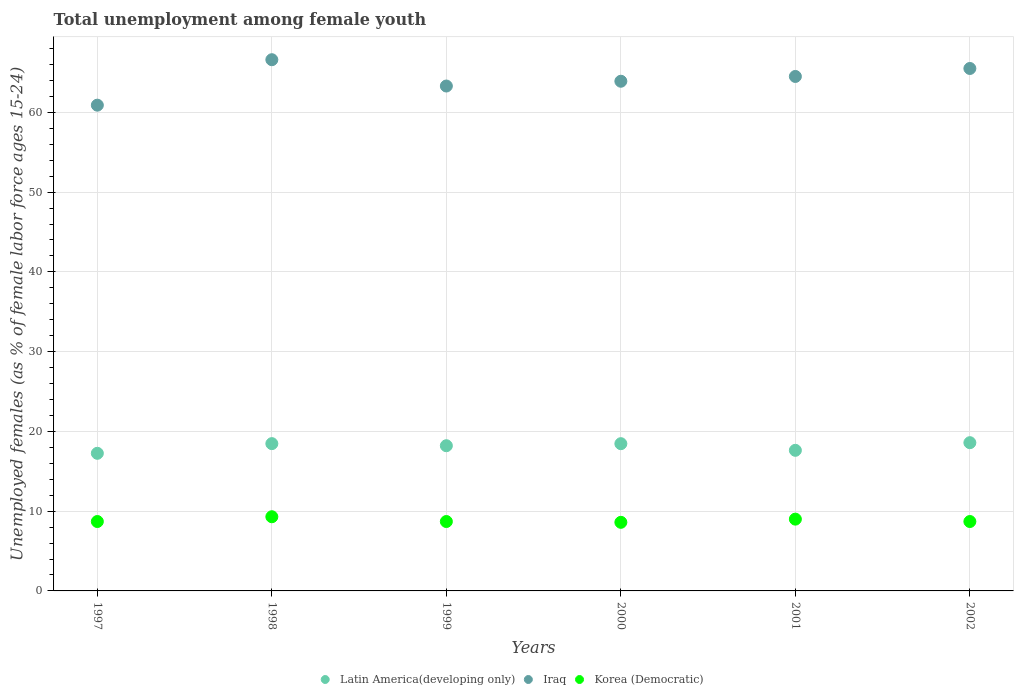What is the percentage of unemployed females in in Latin America(developing only) in 2001?
Provide a succinct answer. 17.63. Across all years, what is the maximum percentage of unemployed females in in Korea (Democratic)?
Keep it short and to the point. 9.3. Across all years, what is the minimum percentage of unemployed females in in Latin America(developing only)?
Offer a very short reply. 17.25. In which year was the percentage of unemployed females in in Korea (Democratic) maximum?
Offer a very short reply. 1998. What is the total percentage of unemployed females in in Latin America(developing only) in the graph?
Provide a succinct answer. 108.59. What is the difference between the percentage of unemployed females in in Korea (Democratic) in 1998 and that in 1999?
Offer a terse response. 0.6. What is the difference between the percentage of unemployed females in in Latin America(developing only) in 2002 and the percentage of unemployed females in in Iraq in 2001?
Give a very brief answer. -45.91. What is the average percentage of unemployed females in in Latin America(developing only) per year?
Provide a succinct answer. 18.1. In the year 1998, what is the difference between the percentage of unemployed females in in Korea (Democratic) and percentage of unemployed females in in Latin America(developing only)?
Make the answer very short. -9.17. In how many years, is the percentage of unemployed females in in Latin America(developing only) greater than 42 %?
Your answer should be very brief. 0. What is the ratio of the percentage of unemployed females in in Latin America(developing only) in 1998 to that in 2002?
Your answer should be very brief. 0.99. Is the percentage of unemployed females in in Iraq in 2000 less than that in 2001?
Your response must be concise. Yes. Is the difference between the percentage of unemployed females in in Korea (Democratic) in 1997 and 2000 greater than the difference between the percentage of unemployed females in in Latin America(developing only) in 1997 and 2000?
Your answer should be compact. Yes. What is the difference between the highest and the second highest percentage of unemployed females in in Korea (Democratic)?
Keep it short and to the point. 0.3. What is the difference between the highest and the lowest percentage of unemployed females in in Korea (Democratic)?
Your answer should be compact. 0.7. Does the percentage of unemployed females in in Iraq monotonically increase over the years?
Offer a very short reply. No. Is the percentage of unemployed females in in Korea (Democratic) strictly greater than the percentage of unemployed females in in Latin America(developing only) over the years?
Your answer should be compact. No. How many years are there in the graph?
Ensure brevity in your answer.  6. Are the values on the major ticks of Y-axis written in scientific E-notation?
Your response must be concise. No. Does the graph contain grids?
Provide a succinct answer. Yes. Where does the legend appear in the graph?
Give a very brief answer. Bottom center. How many legend labels are there?
Offer a terse response. 3. What is the title of the graph?
Give a very brief answer. Total unemployment among female youth. Does "East Asia (developing only)" appear as one of the legend labels in the graph?
Provide a succinct answer. No. What is the label or title of the X-axis?
Provide a short and direct response. Years. What is the label or title of the Y-axis?
Your answer should be compact. Unemployed females (as % of female labor force ages 15-24). What is the Unemployed females (as % of female labor force ages 15-24) in Latin America(developing only) in 1997?
Give a very brief answer. 17.25. What is the Unemployed females (as % of female labor force ages 15-24) of Iraq in 1997?
Give a very brief answer. 60.9. What is the Unemployed females (as % of female labor force ages 15-24) in Korea (Democratic) in 1997?
Ensure brevity in your answer.  8.7. What is the Unemployed females (as % of female labor force ages 15-24) in Latin America(developing only) in 1998?
Keep it short and to the point. 18.47. What is the Unemployed females (as % of female labor force ages 15-24) of Iraq in 1998?
Provide a succinct answer. 66.6. What is the Unemployed females (as % of female labor force ages 15-24) in Korea (Democratic) in 1998?
Your response must be concise. 9.3. What is the Unemployed females (as % of female labor force ages 15-24) in Latin America(developing only) in 1999?
Give a very brief answer. 18.2. What is the Unemployed females (as % of female labor force ages 15-24) of Iraq in 1999?
Your answer should be very brief. 63.3. What is the Unemployed females (as % of female labor force ages 15-24) in Korea (Democratic) in 1999?
Provide a succinct answer. 8.7. What is the Unemployed females (as % of female labor force ages 15-24) in Latin America(developing only) in 2000?
Keep it short and to the point. 18.46. What is the Unemployed females (as % of female labor force ages 15-24) of Iraq in 2000?
Offer a very short reply. 63.9. What is the Unemployed females (as % of female labor force ages 15-24) in Korea (Democratic) in 2000?
Provide a short and direct response. 8.6. What is the Unemployed females (as % of female labor force ages 15-24) in Latin America(developing only) in 2001?
Your answer should be compact. 17.63. What is the Unemployed females (as % of female labor force ages 15-24) of Iraq in 2001?
Offer a very short reply. 64.5. What is the Unemployed females (as % of female labor force ages 15-24) in Latin America(developing only) in 2002?
Provide a short and direct response. 18.59. What is the Unemployed females (as % of female labor force ages 15-24) of Iraq in 2002?
Your answer should be very brief. 65.5. What is the Unemployed females (as % of female labor force ages 15-24) of Korea (Democratic) in 2002?
Your answer should be compact. 8.7. Across all years, what is the maximum Unemployed females (as % of female labor force ages 15-24) of Latin America(developing only)?
Ensure brevity in your answer.  18.59. Across all years, what is the maximum Unemployed females (as % of female labor force ages 15-24) of Iraq?
Make the answer very short. 66.6. Across all years, what is the maximum Unemployed females (as % of female labor force ages 15-24) of Korea (Democratic)?
Provide a short and direct response. 9.3. Across all years, what is the minimum Unemployed females (as % of female labor force ages 15-24) in Latin America(developing only)?
Provide a succinct answer. 17.25. Across all years, what is the minimum Unemployed females (as % of female labor force ages 15-24) in Iraq?
Keep it short and to the point. 60.9. Across all years, what is the minimum Unemployed females (as % of female labor force ages 15-24) in Korea (Democratic)?
Provide a short and direct response. 8.6. What is the total Unemployed females (as % of female labor force ages 15-24) of Latin America(developing only) in the graph?
Give a very brief answer. 108.59. What is the total Unemployed females (as % of female labor force ages 15-24) of Iraq in the graph?
Offer a very short reply. 384.7. What is the total Unemployed females (as % of female labor force ages 15-24) of Korea (Democratic) in the graph?
Your response must be concise. 53. What is the difference between the Unemployed females (as % of female labor force ages 15-24) of Latin America(developing only) in 1997 and that in 1998?
Offer a very short reply. -1.21. What is the difference between the Unemployed females (as % of female labor force ages 15-24) in Iraq in 1997 and that in 1998?
Provide a short and direct response. -5.7. What is the difference between the Unemployed females (as % of female labor force ages 15-24) in Latin America(developing only) in 1997 and that in 1999?
Your answer should be very brief. -0.95. What is the difference between the Unemployed females (as % of female labor force ages 15-24) of Iraq in 1997 and that in 1999?
Offer a very short reply. -2.4. What is the difference between the Unemployed females (as % of female labor force ages 15-24) of Latin America(developing only) in 1997 and that in 2000?
Provide a succinct answer. -1.21. What is the difference between the Unemployed females (as % of female labor force ages 15-24) in Iraq in 1997 and that in 2000?
Provide a succinct answer. -3. What is the difference between the Unemployed females (as % of female labor force ages 15-24) of Korea (Democratic) in 1997 and that in 2000?
Your response must be concise. 0.1. What is the difference between the Unemployed females (as % of female labor force ages 15-24) in Latin America(developing only) in 1997 and that in 2001?
Keep it short and to the point. -0.37. What is the difference between the Unemployed females (as % of female labor force ages 15-24) of Latin America(developing only) in 1997 and that in 2002?
Provide a succinct answer. -1.33. What is the difference between the Unemployed females (as % of female labor force ages 15-24) in Korea (Democratic) in 1997 and that in 2002?
Your answer should be compact. 0. What is the difference between the Unemployed females (as % of female labor force ages 15-24) in Latin America(developing only) in 1998 and that in 1999?
Provide a succinct answer. 0.26. What is the difference between the Unemployed females (as % of female labor force ages 15-24) in Korea (Democratic) in 1998 and that in 1999?
Your answer should be very brief. 0.6. What is the difference between the Unemployed females (as % of female labor force ages 15-24) in Latin America(developing only) in 1998 and that in 2000?
Your answer should be compact. 0.01. What is the difference between the Unemployed females (as % of female labor force ages 15-24) of Iraq in 1998 and that in 2000?
Your answer should be compact. 2.7. What is the difference between the Unemployed females (as % of female labor force ages 15-24) of Latin America(developing only) in 1998 and that in 2001?
Provide a succinct answer. 0.84. What is the difference between the Unemployed females (as % of female labor force ages 15-24) in Korea (Democratic) in 1998 and that in 2001?
Keep it short and to the point. 0.3. What is the difference between the Unemployed females (as % of female labor force ages 15-24) of Latin America(developing only) in 1998 and that in 2002?
Your answer should be compact. -0.12. What is the difference between the Unemployed females (as % of female labor force ages 15-24) of Iraq in 1998 and that in 2002?
Provide a succinct answer. 1.1. What is the difference between the Unemployed females (as % of female labor force ages 15-24) of Korea (Democratic) in 1998 and that in 2002?
Your response must be concise. 0.6. What is the difference between the Unemployed females (as % of female labor force ages 15-24) of Latin America(developing only) in 1999 and that in 2000?
Keep it short and to the point. -0.26. What is the difference between the Unemployed females (as % of female labor force ages 15-24) in Iraq in 1999 and that in 2000?
Provide a short and direct response. -0.6. What is the difference between the Unemployed females (as % of female labor force ages 15-24) in Latin America(developing only) in 1999 and that in 2001?
Give a very brief answer. 0.58. What is the difference between the Unemployed females (as % of female labor force ages 15-24) in Korea (Democratic) in 1999 and that in 2001?
Provide a short and direct response. -0.3. What is the difference between the Unemployed females (as % of female labor force ages 15-24) in Latin America(developing only) in 1999 and that in 2002?
Offer a very short reply. -0.38. What is the difference between the Unemployed females (as % of female labor force ages 15-24) of Latin America(developing only) in 2000 and that in 2001?
Your answer should be very brief. 0.83. What is the difference between the Unemployed females (as % of female labor force ages 15-24) in Korea (Democratic) in 2000 and that in 2001?
Offer a very short reply. -0.4. What is the difference between the Unemployed females (as % of female labor force ages 15-24) in Latin America(developing only) in 2000 and that in 2002?
Offer a very short reply. -0.13. What is the difference between the Unemployed females (as % of female labor force ages 15-24) of Korea (Democratic) in 2000 and that in 2002?
Ensure brevity in your answer.  -0.1. What is the difference between the Unemployed females (as % of female labor force ages 15-24) of Latin America(developing only) in 2001 and that in 2002?
Make the answer very short. -0.96. What is the difference between the Unemployed females (as % of female labor force ages 15-24) in Iraq in 2001 and that in 2002?
Keep it short and to the point. -1. What is the difference between the Unemployed females (as % of female labor force ages 15-24) of Latin America(developing only) in 1997 and the Unemployed females (as % of female labor force ages 15-24) of Iraq in 1998?
Offer a very short reply. -49.35. What is the difference between the Unemployed females (as % of female labor force ages 15-24) of Latin America(developing only) in 1997 and the Unemployed females (as % of female labor force ages 15-24) of Korea (Democratic) in 1998?
Your answer should be compact. 7.95. What is the difference between the Unemployed females (as % of female labor force ages 15-24) in Iraq in 1997 and the Unemployed females (as % of female labor force ages 15-24) in Korea (Democratic) in 1998?
Provide a succinct answer. 51.6. What is the difference between the Unemployed females (as % of female labor force ages 15-24) of Latin America(developing only) in 1997 and the Unemployed females (as % of female labor force ages 15-24) of Iraq in 1999?
Provide a succinct answer. -46.05. What is the difference between the Unemployed females (as % of female labor force ages 15-24) of Latin America(developing only) in 1997 and the Unemployed females (as % of female labor force ages 15-24) of Korea (Democratic) in 1999?
Provide a succinct answer. 8.55. What is the difference between the Unemployed females (as % of female labor force ages 15-24) of Iraq in 1997 and the Unemployed females (as % of female labor force ages 15-24) of Korea (Democratic) in 1999?
Ensure brevity in your answer.  52.2. What is the difference between the Unemployed females (as % of female labor force ages 15-24) of Latin America(developing only) in 1997 and the Unemployed females (as % of female labor force ages 15-24) of Iraq in 2000?
Keep it short and to the point. -46.65. What is the difference between the Unemployed females (as % of female labor force ages 15-24) in Latin America(developing only) in 1997 and the Unemployed females (as % of female labor force ages 15-24) in Korea (Democratic) in 2000?
Offer a very short reply. 8.65. What is the difference between the Unemployed females (as % of female labor force ages 15-24) of Iraq in 1997 and the Unemployed females (as % of female labor force ages 15-24) of Korea (Democratic) in 2000?
Offer a terse response. 52.3. What is the difference between the Unemployed females (as % of female labor force ages 15-24) in Latin America(developing only) in 1997 and the Unemployed females (as % of female labor force ages 15-24) in Iraq in 2001?
Offer a very short reply. -47.25. What is the difference between the Unemployed females (as % of female labor force ages 15-24) in Latin America(developing only) in 1997 and the Unemployed females (as % of female labor force ages 15-24) in Korea (Democratic) in 2001?
Ensure brevity in your answer.  8.25. What is the difference between the Unemployed females (as % of female labor force ages 15-24) in Iraq in 1997 and the Unemployed females (as % of female labor force ages 15-24) in Korea (Democratic) in 2001?
Offer a very short reply. 51.9. What is the difference between the Unemployed females (as % of female labor force ages 15-24) of Latin America(developing only) in 1997 and the Unemployed females (as % of female labor force ages 15-24) of Iraq in 2002?
Make the answer very short. -48.25. What is the difference between the Unemployed females (as % of female labor force ages 15-24) of Latin America(developing only) in 1997 and the Unemployed females (as % of female labor force ages 15-24) of Korea (Democratic) in 2002?
Your response must be concise. 8.55. What is the difference between the Unemployed females (as % of female labor force ages 15-24) in Iraq in 1997 and the Unemployed females (as % of female labor force ages 15-24) in Korea (Democratic) in 2002?
Your answer should be compact. 52.2. What is the difference between the Unemployed females (as % of female labor force ages 15-24) in Latin America(developing only) in 1998 and the Unemployed females (as % of female labor force ages 15-24) in Iraq in 1999?
Your response must be concise. -44.83. What is the difference between the Unemployed females (as % of female labor force ages 15-24) of Latin America(developing only) in 1998 and the Unemployed females (as % of female labor force ages 15-24) of Korea (Democratic) in 1999?
Offer a very short reply. 9.77. What is the difference between the Unemployed females (as % of female labor force ages 15-24) in Iraq in 1998 and the Unemployed females (as % of female labor force ages 15-24) in Korea (Democratic) in 1999?
Provide a succinct answer. 57.9. What is the difference between the Unemployed females (as % of female labor force ages 15-24) in Latin America(developing only) in 1998 and the Unemployed females (as % of female labor force ages 15-24) in Iraq in 2000?
Offer a terse response. -45.43. What is the difference between the Unemployed females (as % of female labor force ages 15-24) of Latin America(developing only) in 1998 and the Unemployed females (as % of female labor force ages 15-24) of Korea (Democratic) in 2000?
Provide a succinct answer. 9.87. What is the difference between the Unemployed females (as % of female labor force ages 15-24) in Iraq in 1998 and the Unemployed females (as % of female labor force ages 15-24) in Korea (Democratic) in 2000?
Provide a short and direct response. 58. What is the difference between the Unemployed females (as % of female labor force ages 15-24) of Latin America(developing only) in 1998 and the Unemployed females (as % of female labor force ages 15-24) of Iraq in 2001?
Ensure brevity in your answer.  -46.03. What is the difference between the Unemployed females (as % of female labor force ages 15-24) of Latin America(developing only) in 1998 and the Unemployed females (as % of female labor force ages 15-24) of Korea (Democratic) in 2001?
Provide a short and direct response. 9.47. What is the difference between the Unemployed females (as % of female labor force ages 15-24) in Iraq in 1998 and the Unemployed females (as % of female labor force ages 15-24) in Korea (Democratic) in 2001?
Ensure brevity in your answer.  57.6. What is the difference between the Unemployed females (as % of female labor force ages 15-24) in Latin America(developing only) in 1998 and the Unemployed females (as % of female labor force ages 15-24) in Iraq in 2002?
Your response must be concise. -47.03. What is the difference between the Unemployed females (as % of female labor force ages 15-24) in Latin America(developing only) in 1998 and the Unemployed females (as % of female labor force ages 15-24) in Korea (Democratic) in 2002?
Offer a very short reply. 9.77. What is the difference between the Unemployed females (as % of female labor force ages 15-24) in Iraq in 1998 and the Unemployed females (as % of female labor force ages 15-24) in Korea (Democratic) in 2002?
Make the answer very short. 57.9. What is the difference between the Unemployed females (as % of female labor force ages 15-24) in Latin America(developing only) in 1999 and the Unemployed females (as % of female labor force ages 15-24) in Iraq in 2000?
Ensure brevity in your answer.  -45.7. What is the difference between the Unemployed females (as % of female labor force ages 15-24) of Latin America(developing only) in 1999 and the Unemployed females (as % of female labor force ages 15-24) of Korea (Democratic) in 2000?
Provide a succinct answer. 9.6. What is the difference between the Unemployed females (as % of female labor force ages 15-24) of Iraq in 1999 and the Unemployed females (as % of female labor force ages 15-24) of Korea (Democratic) in 2000?
Your answer should be compact. 54.7. What is the difference between the Unemployed females (as % of female labor force ages 15-24) of Latin America(developing only) in 1999 and the Unemployed females (as % of female labor force ages 15-24) of Iraq in 2001?
Make the answer very short. -46.3. What is the difference between the Unemployed females (as % of female labor force ages 15-24) of Latin America(developing only) in 1999 and the Unemployed females (as % of female labor force ages 15-24) of Korea (Democratic) in 2001?
Give a very brief answer. 9.2. What is the difference between the Unemployed females (as % of female labor force ages 15-24) in Iraq in 1999 and the Unemployed females (as % of female labor force ages 15-24) in Korea (Democratic) in 2001?
Your answer should be compact. 54.3. What is the difference between the Unemployed females (as % of female labor force ages 15-24) of Latin America(developing only) in 1999 and the Unemployed females (as % of female labor force ages 15-24) of Iraq in 2002?
Offer a terse response. -47.3. What is the difference between the Unemployed females (as % of female labor force ages 15-24) in Latin America(developing only) in 1999 and the Unemployed females (as % of female labor force ages 15-24) in Korea (Democratic) in 2002?
Offer a very short reply. 9.5. What is the difference between the Unemployed females (as % of female labor force ages 15-24) of Iraq in 1999 and the Unemployed females (as % of female labor force ages 15-24) of Korea (Democratic) in 2002?
Your response must be concise. 54.6. What is the difference between the Unemployed females (as % of female labor force ages 15-24) of Latin America(developing only) in 2000 and the Unemployed females (as % of female labor force ages 15-24) of Iraq in 2001?
Your answer should be compact. -46.04. What is the difference between the Unemployed females (as % of female labor force ages 15-24) in Latin America(developing only) in 2000 and the Unemployed females (as % of female labor force ages 15-24) in Korea (Democratic) in 2001?
Your answer should be compact. 9.46. What is the difference between the Unemployed females (as % of female labor force ages 15-24) in Iraq in 2000 and the Unemployed females (as % of female labor force ages 15-24) in Korea (Democratic) in 2001?
Ensure brevity in your answer.  54.9. What is the difference between the Unemployed females (as % of female labor force ages 15-24) in Latin America(developing only) in 2000 and the Unemployed females (as % of female labor force ages 15-24) in Iraq in 2002?
Provide a succinct answer. -47.04. What is the difference between the Unemployed females (as % of female labor force ages 15-24) in Latin America(developing only) in 2000 and the Unemployed females (as % of female labor force ages 15-24) in Korea (Democratic) in 2002?
Make the answer very short. 9.76. What is the difference between the Unemployed females (as % of female labor force ages 15-24) of Iraq in 2000 and the Unemployed females (as % of female labor force ages 15-24) of Korea (Democratic) in 2002?
Offer a very short reply. 55.2. What is the difference between the Unemployed females (as % of female labor force ages 15-24) of Latin America(developing only) in 2001 and the Unemployed females (as % of female labor force ages 15-24) of Iraq in 2002?
Give a very brief answer. -47.87. What is the difference between the Unemployed females (as % of female labor force ages 15-24) of Latin America(developing only) in 2001 and the Unemployed females (as % of female labor force ages 15-24) of Korea (Democratic) in 2002?
Keep it short and to the point. 8.93. What is the difference between the Unemployed females (as % of female labor force ages 15-24) of Iraq in 2001 and the Unemployed females (as % of female labor force ages 15-24) of Korea (Democratic) in 2002?
Give a very brief answer. 55.8. What is the average Unemployed females (as % of female labor force ages 15-24) in Latin America(developing only) per year?
Ensure brevity in your answer.  18.1. What is the average Unemployed females (as % of female labor force ages 15-24) in Iraq per year?
Ensure brevity in your answer.  64.12. What is the average Unemployed females (as % of female labor force ages 15-24) of Korea (Democratic) per year?
Your answer should be very brief. 8.83. In the year 1997, what is the difference between the Unemployed females (as % of female labor force ages 15-24) in Latin America(developing only) and Unemployed females (as % of female labor force ages 15-24) in Iraq?
Give a very brief answer. -43.65. In the year 1997, what is the difference between the Unemployed females (as % of female labor force ages 15-24) in Latin America(developing only) and Unemployed females (as % of female labor force ages 15-24) in Korea (Democratic)?
Offer a terse response. 8.55. In the year 1997, what is the difference between the Unemployed females (as % of female labor force ages 15-24) of Iraq and Unemployed females (as % of female labor force ages 15-24) of Korea (Democratic)?
Offer a terse response. 52.2. In the year 1998, what is the difference between the Unemployed females (as % of female labor force ages 15-24) of Latin America(developing only) and Unemployed females (as % of female labor force ages 15-24) of Iraq?
Your response must be concise. -48.13. In the year 1998, what is the difference between the Unemployed females (as % of female labor force ages 15-24) in Latin America(developing only) and Unemployed females (as % of female labor force ages 15-24) in Korea (Democratic)?
Ensure brevity in your answer.  9.17. In the year 1998, what is the difference between the Unemployed females (as % of female labor force ages 15-24) of Iraq and Unemployed females (as % of female labor force ages 15-24) of Korea (Democratic)?
Your answer should be very brief. 57.3. In the year 1999, what is the difference between the Unemployed females (as % of female labor force ages 15-24) in Latin America(developing only) and Unemployed females (as % of female labor force ages 15-24) in Iraq?
Provide a short and direct response. -45.1. In the year 1999, what is the difference between the Unemployed females (as % of female labor force ages 15-24) in Latin America(developing only) and Unemployed females (as % of female labor force ages 15-24) in Korea (Democratic)?
Provide a succinct answer. 9.5. In the year 1999, what is the difference between the Unemployed females (as % of female labor force ages 15-24) in Iraq and Unemployed females (as % of female labor force ages 15-24) in Korea (Democratic)?
Keep it short and to the point. 54.6. In the year 2000, what is the difference between the Unemployed females (as % of female labor force ages 15-24) in Latin America(developing only) and Unemployed females (as % of female labor force ages 15-24) in Iraq?
Ensure brevity in your answer.  -45.44. In the year 2000, what is the difference between the Unemployed females (as % of female labor force ages 15-24) in Latin America(developing only) and Unemployed females (as % of female labor force ages 15-24) in Korea (Democratic)?
Provide a short and direct response. 9.86. In the year 2000, what is the difference between the Unemployed females (as % of female labor force ages 15-24) in Iraq and Unemployed females (as % of female labor force ages 15-24) in Korea (Democratic)?
Make the answer very short. 55.3. In the year 2001, what is the difference between the Unemployed females (as % of female labor force ages 15-24) of Latin America(developing only) and Unemployed females (as % of female labor force ages 15-24) of Iraq?
Make the answer very short. -46.87. In the year 2001, what is the difference between the Unemployed females (as % of female labor force ages 15-24) in Latin America(developing only) and Unemployed females (as % of female labor force ages 15-24) in Korea (Democratic)?
Ensure brevity in your answer.  8.63. In the year 2001, what is the difference between the Unemployed females (as % of female labor force ages 15-24) in Iraq and Unemployed females (as % of female labor force ages 15-24) in Korea (Democratic)?
Keep it short and to the point. 55.5. In the year 2002, what is the difference between the Unemployed females (as % of female labor force ages 15-24) in Latin America(developing only) and Unemployed females (as % of female labor force ages 15-24) in Iraq?
Give a very brief answer. -46.91. In the year 2002, what is the difference between the Unemployed females (as % of female labor force ages 15-24) of Latin America(developing only) and Unemployed females (as % of female labor force ages 15-24) of Korea (Democratic)?
Make the answer very short. 9.88. In the year 2002, what is the difference between the Unemployed females (as % of female labor force ages 15-24) in Iraq and Unemployed females (as % of female labor force ages 15-24) in Korea (Democratic)?
Make the answer very short. 56.8. What is the ratio of the Unemployed females (as % of female labor force ages 15-24) of Latin America(developing only) in 1997 to that in 1998?
Provide a short and direct response. 0.93. What is the ratio of the Unemployed females (as % of female labor force ages 15-24) of Iraq in 1997 to that in 1998?
Keep it short and to the point. 0.91. What is the ratio of the Unemployed females (as % of female labor force ages 15-24) in Korea (Democratic) in 1997 to that in 1998?
Provide a succinct answer. 0.94. What is the ratio of the Unemployed females (as % of female labor force ages 15-24) in Latin America(developing only) in 1997 to that in 1999?
Ensure brevity in your answer.  0.95. What is the ratio of the Unemployed females (as % of female labor force ages 15-24) of Iraq in 1997 to that in 1999?
Provide a short and direct response. 0.96. What is the ratio of the Unemployed females (as % of female labor force ages 15-24) in Latin America(developing only) in 1997 to that in 2000?
Give a very brief answer. 0.93. What is the ratio of the Unemployed females (as % of female labor force ages 15-24) in Iraq in 1997 to that in 2000?
Give a very brief answer. 0.95. What is the ratio of the Unemployed females (as % of female labor force ages 15-24) in Korea (Democratic) in 1997 to that in 2000?
Make the answer very short. 1.01. What is the ratio of the Unemployed females (as % of female labor force ages 15-24) in Latin America(developing only) in 1997 to that in 2001?
Ensure brevity in your answer.  0.98. What is the ratio of the Unemployed females (as % of female labor force ages 15-24) in Iraq in 1997 to that in 2001?
Give a very brief answer. 0.94. What is the ratio of the Unemployed females (as % of female labor force ages 15-24) in Korea (Democratic) in 1997 to that in 2001?
Ensure brevity in your answer.  0.97. What is the ratio of the Unemployed females (as % of female labor force ages 15-24) in Latin America(developing only) in 1997 to that in 2002?
Ensure brevity in your answer.  0.93. What is the ratio of the Unemployed females (as % of female labor force ages 15-24) of Iraq in 1997 to that in 2002?
Your answer should be very brief. 0.93. What is the ratio of the Unemployed females (as % of female labor force ages 15-24) in Korea (Democratic) in 1997 to that in 2002?
Your answer should be very brief. 1. What is the ratio of the Unemployed females (as % of female labor force ages 15-24) of Latin America(developing only) in 1998 to that in 1999?
Ensure brevity in your answer.  1.01. What is the ratio of the Unemployed females (as % of female labor force ages 15-24) of Iraq in 1998 to that in 1999?
Give a very brief answer. 1.05. What is the ratio of the Unemployed females (as % of female labor force ages 15-24) of Korea (Democratic) in 1998 to that in 1999?
Give a very brief answer. 1.07. What is the ratio of the Unemployed females (as % of female labor force ages 15-24) in Iraq in 1998 to that in 2000?
Your answer should be very brief. 1.04. What is the ratio of the Unemployed females (as % of female labor force ages 15-24) of Korea (Democratic) in 1998 to that in 2000?
Provide a succinct answer. 1.08. What is the ratio of the Unemployed females (as % of female labor force ages 15-24) of Latin America(developing only) in 1998 to that in 2001?
Give a very brief answer. 1.05. What is the ratio of the Unemployed females (as % of female labor force ages 15-24) of Iraq in 1998 to that in 2001?
Your answer should be compact. 1.03. What is the ratio of the Unemployed females (as % of female labor force ages 15-24) in Korea (Democratic) in 1998 to that in 2001?
Your answer should be very brief. 1.03. What is the ratio of the Unemployed females (as % of female labor force ages 15-24) in Latin America(developing only) in 1998 to that in 2002?
Give a very brief answer. 0.99. What is the ratio of the Unemployed females (as % of female labor force ages 15-24) in Iraq in 1998 to that in 2002?
Ensure brevity in your answer.  1.02. What is the ratio of the Unemployed females (as % of female labor force ages 15-24) in Korea (Democratic) in 1998 to that in 2002?
Offer a terse response. 1.07. What is the ratio of the Unemployed females (as % of female labor force ages 15-24) of Latin America(developing only) in 1999 to that in 2000?
Provide a short and direct response. 0.99. What is the ratio of the Unemployed females (as % of female labor force ages 15-24) in Iraq in 1999 to that in 2000?
Offer a very short reply. 0.99. What is the ratio of the Unemployed females (as % of female labor force ages 15-24) of Korea (Democratic) in 1999 to that in 2000?
Your response must be concise. 1.01. What is the ratio of the Unemployed females (as % of female labor force ages 15-24) of Latin America(developing only) in 1999 to that in 2001?
Make the answer very short. 1.03. What is the ratio of the Unemployed females (as % of female labor force ages 15-24) of Iraq in 1999 to that in 2001?
Provide a short and direct response. 0.98. What is the ratio of the Unemployed females (as % of female labor force ages 15-24) in Korea (Democratic) in 1999 to that in 2001?
Your answer should be compact. 0.97. What is the ratio of the Unemployed females (as % of female labor force ages 15-24) in Latin America(developing only) in 1999 to that in 2002?
Provide a succinct answer. 0.98. What is the ratio of the Unemployed females (as % of female labor force ages 15-24) in Iraq in 1999 to that in 2002?
Your answer should be compact. 0.97. What is the ratio of the Unemployed females (as % of female labor force ages 15-24) of Korea (Democratic) in 1999 to that in 2002?
Your response must be concise. 1. What is the ratio of the Unemployed females (as % of female labor force ages 15-24) in Latin America(developing only) in 2000 to that in 2001?
Offer a very short reply. 1.05. What is the ratio of the Unemployed females (as % of female labor force ages 15-24) of Korea (Democratic) in 2000 to that in 2001?
Keep it short and to the point. 0.96. What is the ratio of the Unemployed females (as % of female labor force ages 15-24) in Latin America(developing only) in 2000 to that in 2002?
Your response must be concise. 0.99. What is the ratio of the Unemployed females (as % of female labor force ages 15-24) in Iraq in 2000 to that in 2002?
Offer a very short reply. 0.98. What is the ratio of the Unemployed females (as % of female labor force ages 15-24) of Korea (Democratic) in 2000 to that in 2002?
Ensure brevity in your answer.  0.99. What is the ratio of the Unemployed females (as % of female labor force ages 15-24) in Latin America(developing only) in 2001 to that in 2002?
Provide a succinct answer. 0.95. What is the ratio of the Unemployed females (as % of female labor force ages 15-24) of Iraq in 2001 to that in 2002?
Your answer should be compact. 0.98. What is the ratio of the Unemployed females (as % of female labor force ages 15-24) of Korea (Democratic) in 2001 to that in 2002?
Keep it short and to the point. 1.03. What is the difference between the highest and the second highest Unemployed females (as % of female labor force ages 15-24) of Latin America(developing only)?
Give a very brief answer. 0.12. What is the difference between the highest and the second highest Unemployed females (as % of female labor force ages 15-24) of Iraq?
Give a very brief answer. 1.1. What is the difference between the highest and the lowest Unemployed females (as % of female labor force ages 15-24) in Latin America(developing only)?
Give a very brief answer. 1.33. What is the difference between the highest and the lowest Unemployed females (as % of female labor force ages 15-24) in Korea (Democratic)?
Offer a very short reply. 0.7. 